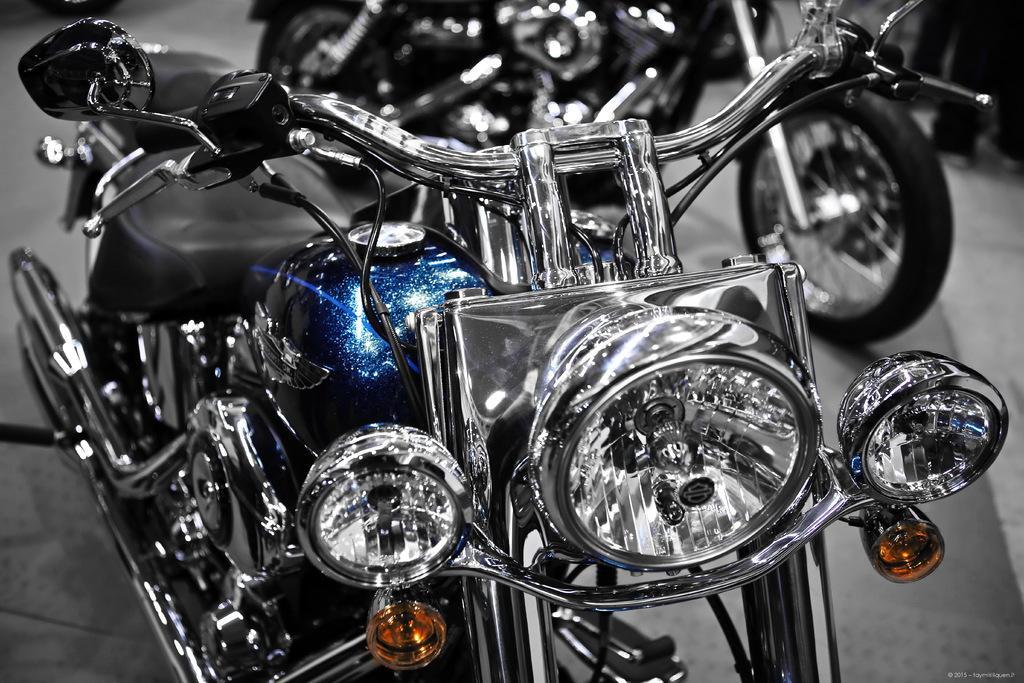Describe this image in one or two sentences. In front of the image there are bikes. On the right side of the image we can see the legs of people. There is some text at the bottom of the image. 